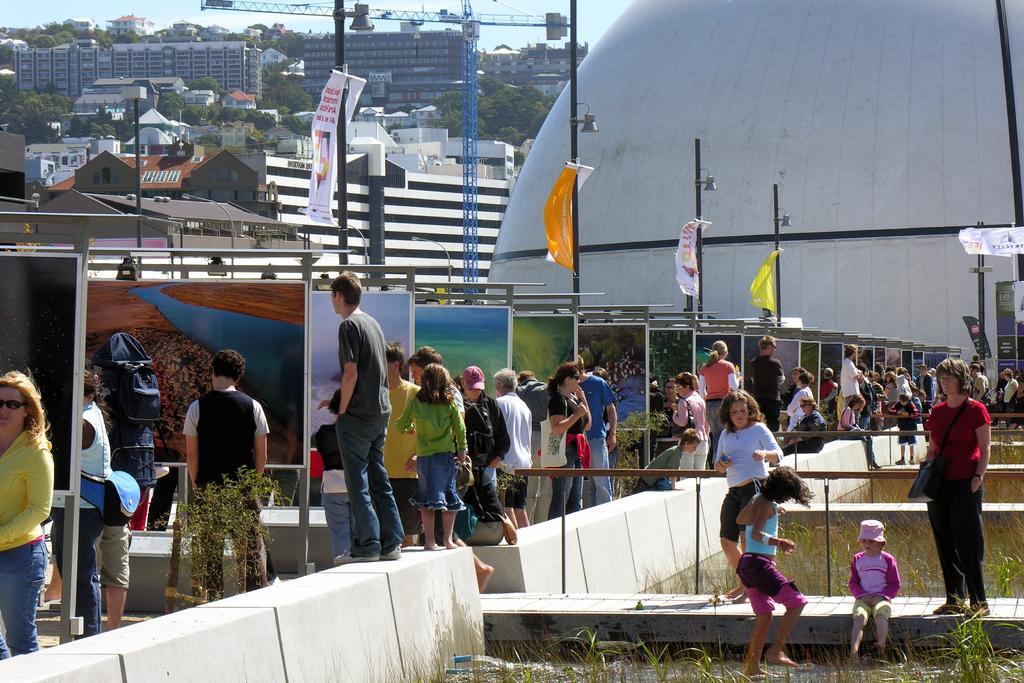How would you summarize this image in a sentence or two? The picture is taken outside a city may be in a painting exhibition. In the foreground of the picture there are people, railing, wall, paintings, banners, poles, street lights, grass and other objects. In the background there are buildings, trees and some machinery. 